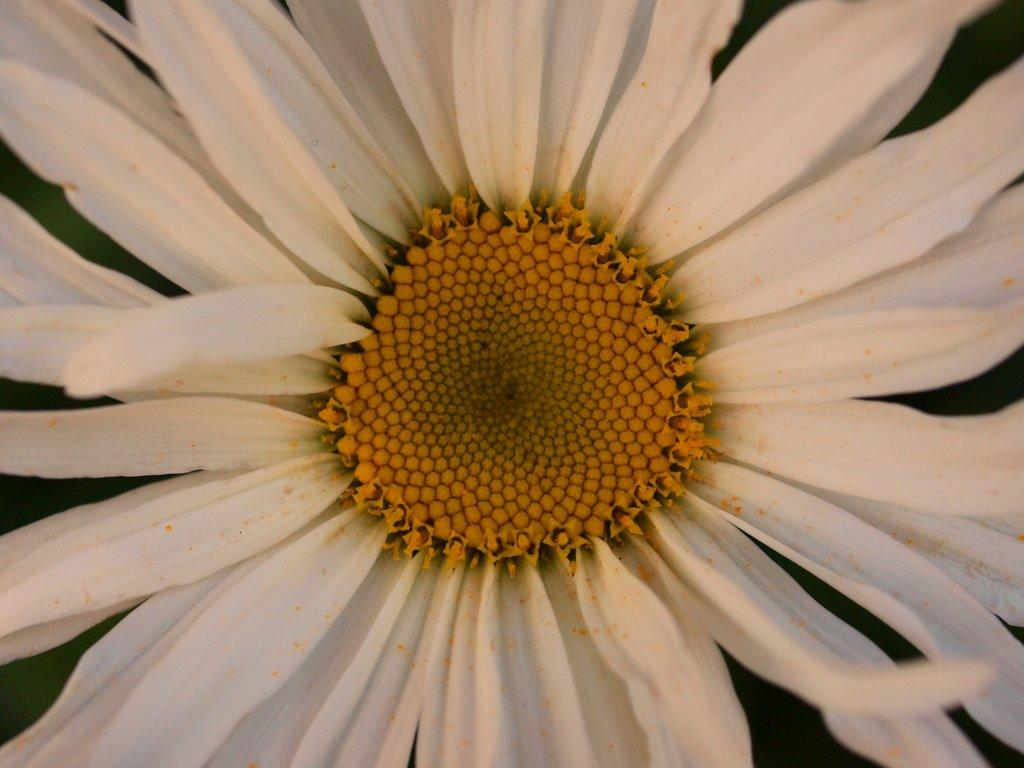What type of flower is visible in the image? There is a white flower in the image. Can you describe the perspective of the image? The image is a zoomed-in picture of the flower. What type of acoustics can be heard coming from the flower in the image? There is no sound or acoustics associated with the flower in the image. What type of nerve is visible in the image? There is no nerve present in the image; it features a white flower. 